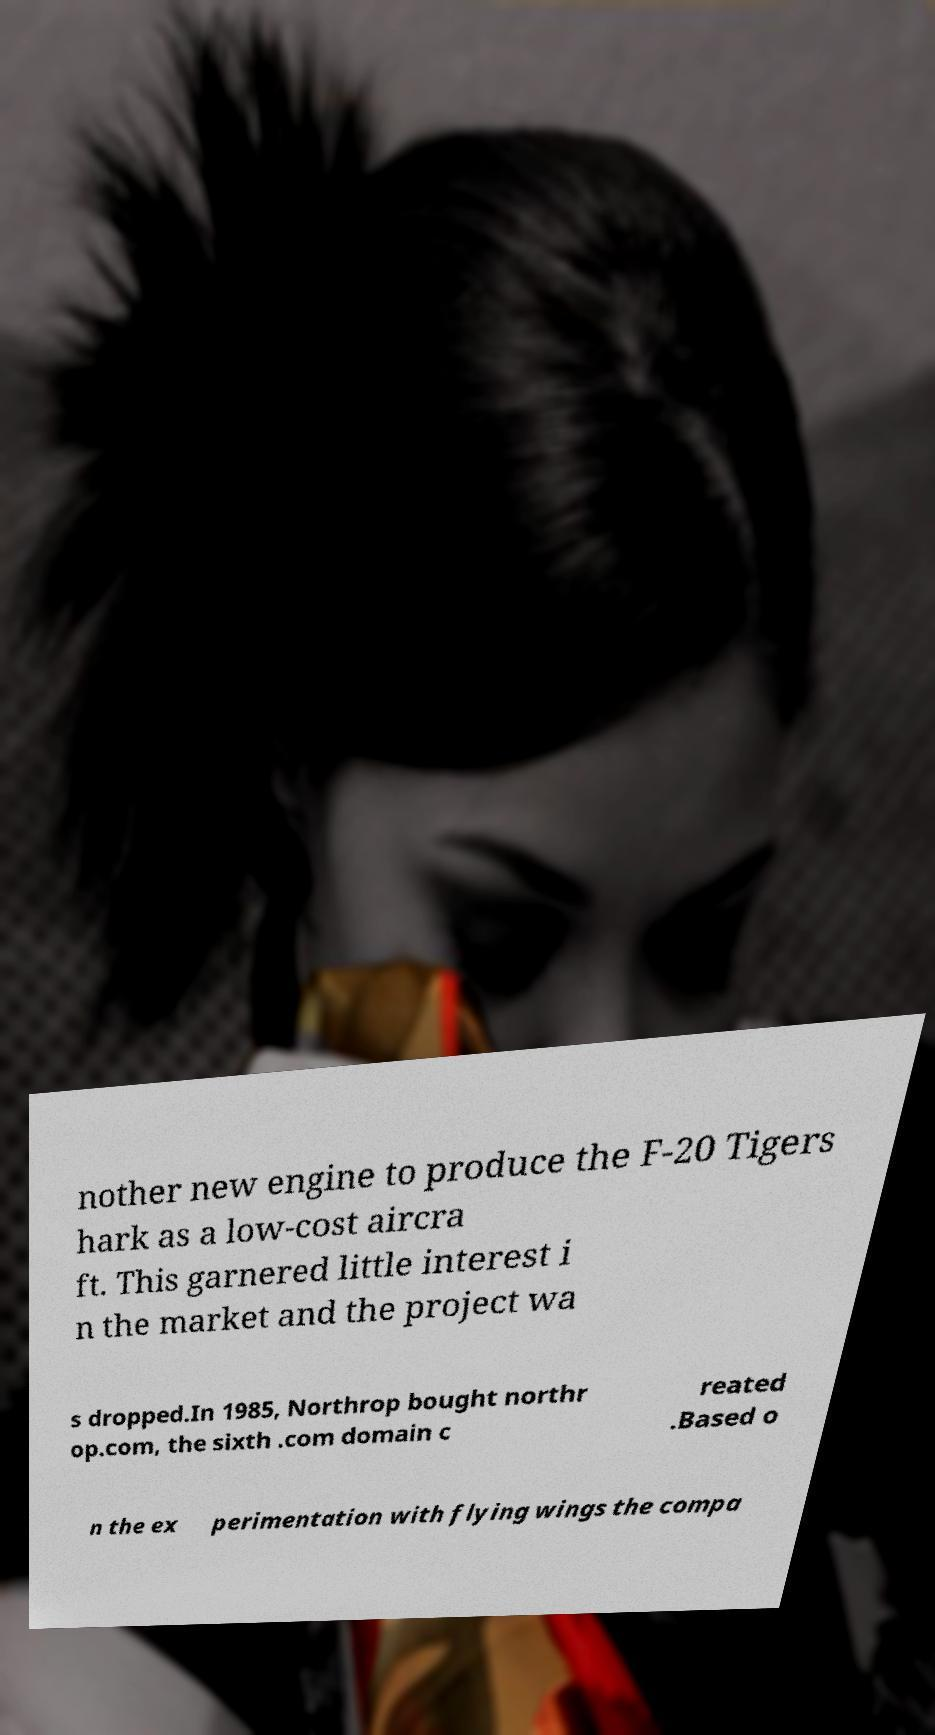Could you assist in decoding the text presented in this image and type it out clearly? nother new engine to produce the F-20 Tigers hark as a low-cost aircra ft. This garnered little interest i n the market and the project wa s dropped.In 1985, Northrop bought northr op.com, the sixth .com domain c reated .Based o n the ex perimentation with flying wings the compa 